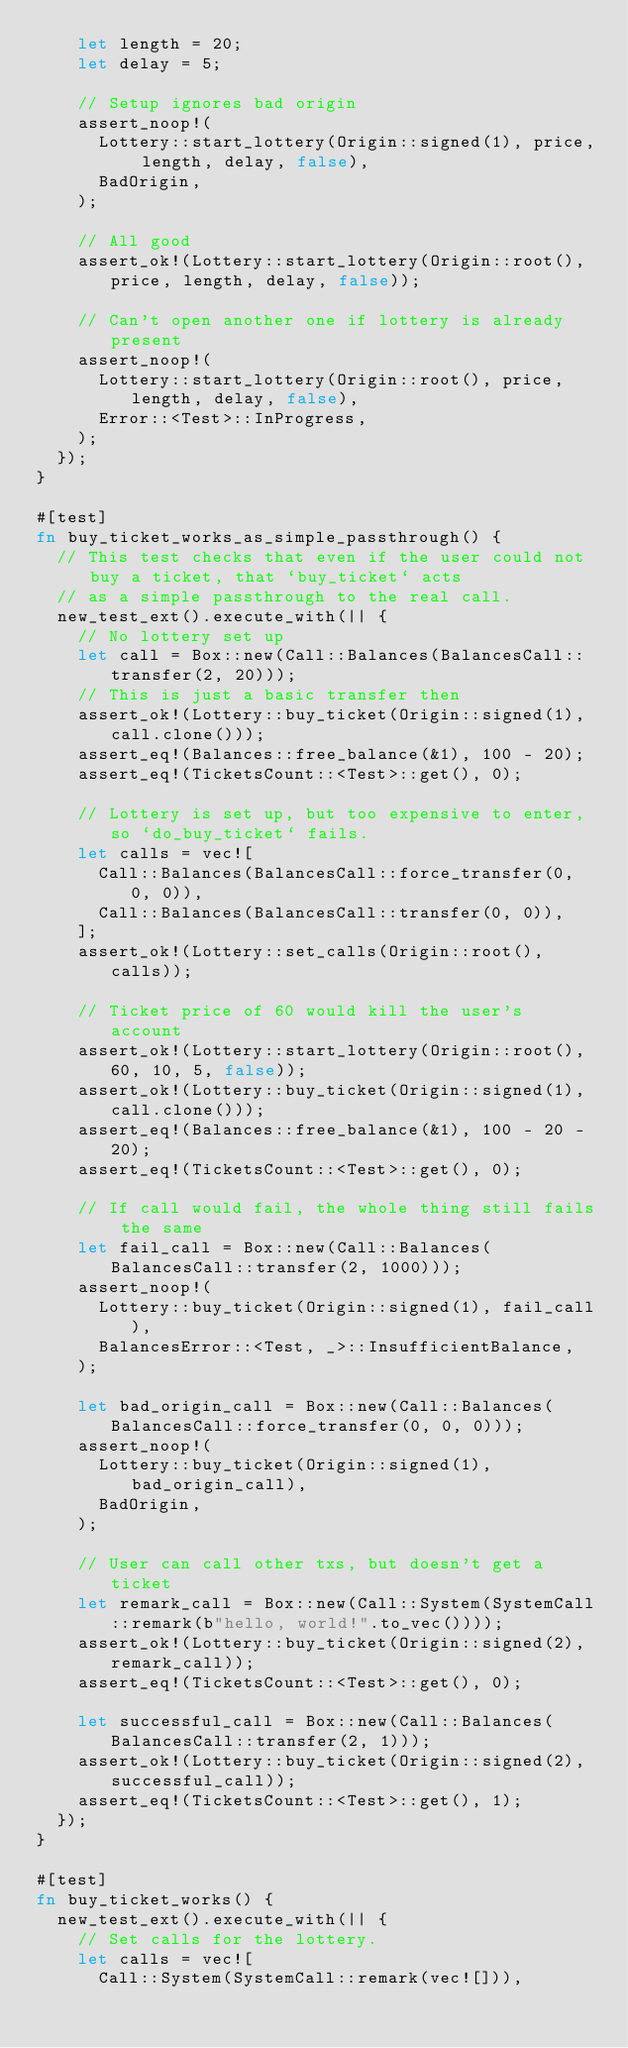Convert code to text. <code><loc_0><loc_0><loc_500><loc_500><_Rust_>		let length = 20;
		let delay = 5;

		// Setup ignores bad origin
		assert_noop!(
			Lottery::start_lottery(Origin::signed(1), price, length, delay, false),
			BadOrigin,
		);

		// All good
		assert_ok!(Lottery::start_lottery(Origin::root(), price, length, delay, false));

		// Can't open another one if lottery is already present
		assert_noop!(
			Lottery::start_lottery(Origin::root(), price, length, delay, false),
			Error::<Test>::InProgress,
		);
	});
}

#[test]
fn buy_ticket_works_as_simple_passthrough() {
	// This test checks that even if the user could not buy a ticket, that `buy_ticket` acts
	// as a simple passthrough to the real call.
	new_test_ext().execute_with(|| {
		// No lottery set up
		let call = Box::new(Call::Balances(BalancesCall::transfer(2, 20)));
		// This is just a basic transfer then
		assert_ok!(Lottery::buy_ticket(Origin::signed(1), call.clone()));
		assert_eq!(Balances::free_balance(&1), 100 - 20);
		assert_eq!(TicketsCount::<Test>::get(), 0);

		// Lottery is set up, but too expensive to enter, so `do_buy_ticket` fails.
		let calls = vec![
			Call::Balances(BalancesCall::force_transfer(0, 0, 0)),
			Call::Balances(BalancesCall::transfer(0, 0)),
		];
		assert_ok!(Lottery::set_calls(Origin::root(), calls));

		// Ticket price of 60 would kill the user's account
		assert_ok!(Lottery::start_lottery(Origin::root(), 60, 10, 5, false));
		assert_ok!(Lottery::buy_ticket(Origin::signed(1), call.clone()));
		assert_eq!(Balances::free_balance(&1), 100 - 20 - 20);
		assert_eq!(TicketsCount::<Test>::get(), 0);

		// If call would fail, the whole thing still fails the same
		let fail_call = Box::new(Call::Balances(BalancesCall::transfer(2, 1000)));
		assert_noop!(
			Lottery::buy_ticket(Origin::signed(1), fail_call),
			BalancesError::<Test, _>::InsufficientBalance,
		);

		let bad_origin_call = Box::new(Call::Balances(BalancesCall::force_transfer(0, 0, 0)));
		assert_noop!(
			Lottery::buy_ticket(Origin::signed(1), bad_origin_call),
			BadOrigin,
		);

		// User can call other txs, but doesn't get a ticket
		let remark_call = Box::new(Call::System(SystemCall::remark(b"hello, world!".to_vec())));
		assert_ok!(Lottery::buy_ticket(Origin::signed(2), remark_call));
		assert_eq!(TicketsCount::<Test>::get(), 0);

		let successful_call = Box::new(Call::Balances(BalancesCall::transfer(2, 1)));
		assert_ok!(Lottery::buy_ticket(Origin::signed(2), successful_call));
		assert_eq!(TicketsCount::<Test>::get(), 1);
	});
}

#[test]
fn buy_ticket_works() {
	new_test_ext().execute_with(|| {
		// Set calls for the lottery.
		let calls = vec![
			Call::System(SystemCall::remark(vec![])),</code> 